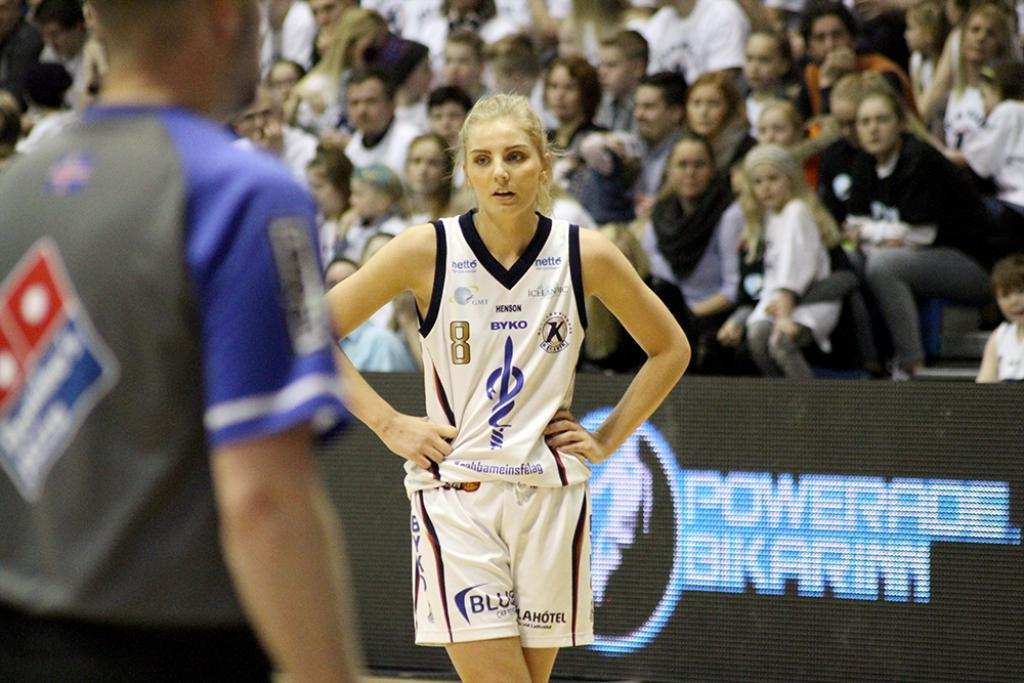<image>
Present a compact description of the photo's key features. A basketball player walks in front of an ad board for Powerade Bikarinn. 